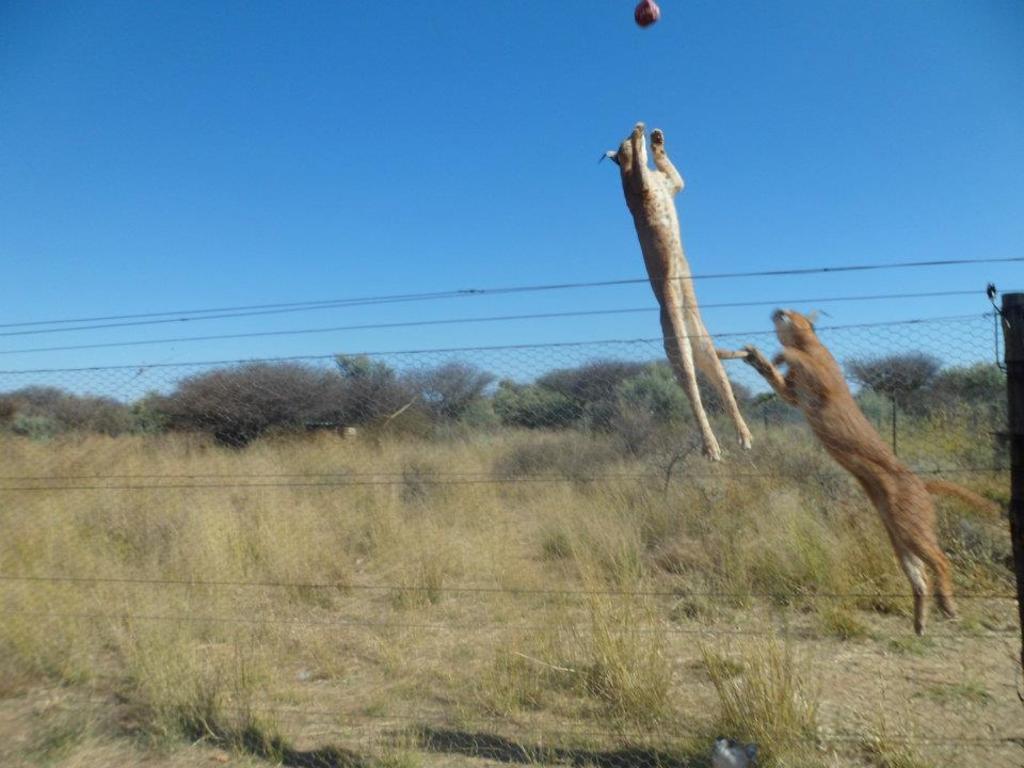How would you summarize this image in a sentence or two? This picture is clicked outside the city. On the right we can see the two animals jumping in the air and there is an object which is in the air and we can see the cables, net, grass, sky and trees. 